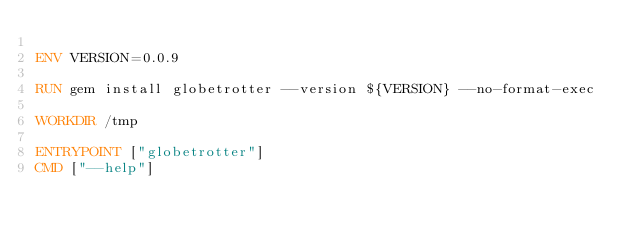<code> <loc_0><loc_0><loc_500><loc_500><_Dockerfile_>
ENV VERSION=0.0.9

RUN gem install globetrotter --version ${VERSION} --no-format-exec

WORKDIR /tmp

ENTRYPOINT ["globetrotter"]
CMD ["--help"]
</code> 